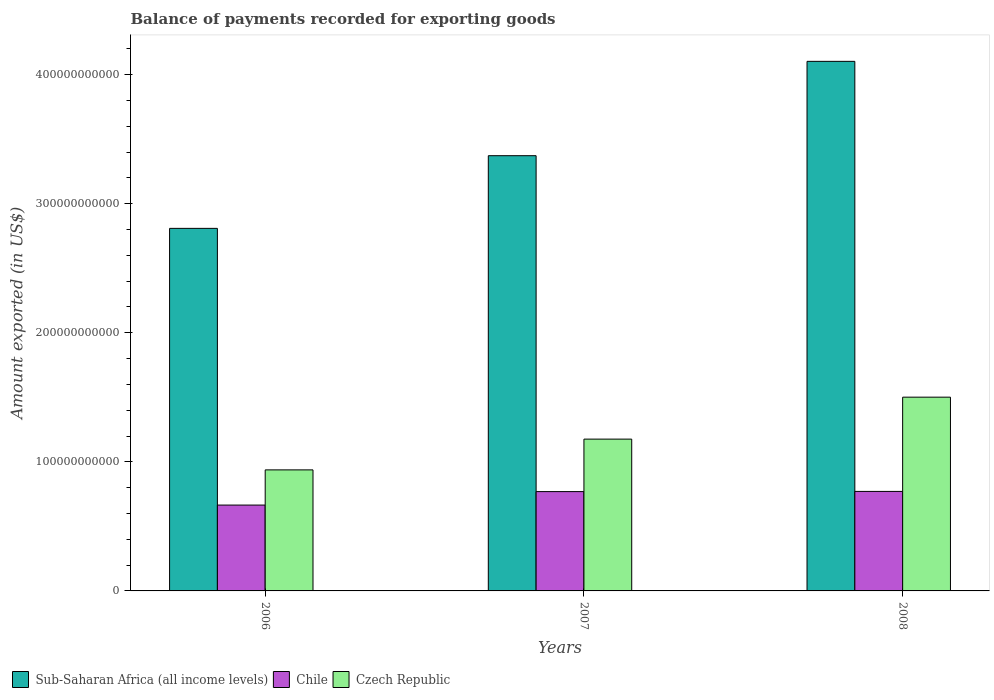How many groups of bars are there?
Offer a terse response. 3. Are the number of bars per tick equal to the number of legend labels?
Your answer should be very brief. Yes. How many bars are there on the 1st tick from the right?
Ensure brevity in your answer.  3. What is the label of the 3rd group of bars from the left?
Give a very brief answer. 2008. What is the amount exported in Chile in 2008?
Your response must be concise. 7.71e+1. Across all years, what is the maximum amount exported in Chile?
Provide a short and direct response. 7.71e+1. Across all years, what is the minimum amount exported in Sub-Saharan Africa (all income levels)?
Your answer should be compact. 2.81e+11. What is the total amount exported in Sub-Saharan Africa (all income levels) in the graph?
Offer a very short reply. 1.03e+12. What is the difference between the amount exported in Chile in 2006 and that in 2007?
Your answer should be compact. -1.04e+1. What is the difference between the amount exported in Chile in 2007 and the amount exported in Czech Republic in 2006?
Keep it short and to the point. -1.68e+1. What is the average amount exported in Sub-Saharan Africa (all income levels) per year?
Give a very brief answer. 3.43e+11. In the year 2006, what is the difference between the amount exported in Chile and amount exported in Czech Republic?
Keep it short and to the point. -2.72e+1. What is the ratio of the amount exported in Sub-Saharan Africa (all income levels) in 2007 to that in 2008?
Provide a succinct answer. 0.82. Is the difference between the amount exported in Chile in 2006 and 2007 greater than the difference between the amount exported in Czech Republic in 2006 and 2007?
Offer a very short reply. Yes. What is the difference between the highest and the second highest amount exported in Sub-Saharan Africa (all income levels)?
Make the answer very short. 7.31e+1. What is the difference between the highest and the lowest amount exported in Chile?
Your answer should be very brief. 1.06e+1. In how many years, is the amount exported in Chile greater than the average amount exported in Chile taken over all years?
Ensure brevity in your answer.  2. What does the 2nd bar from the left in 2006 represents?
Ensure brevity in your answer.  Chile. What does the 3rd bar from the right in 2008 represents?
Keep it short and to the point. Sub-Saharan Africa (all income levels). Is it the case that in every year, the sum of the amount exported in Sub-Saharan Africa (all income levels) and amount exported in Chile is greater than the amount exported in Czech Republic?
Your answer should be compact. Yes. How many bars are there?
Offer a terse response. 9. Are all the bars in the graph horizontal?
Provide a short and direct response. No. What is the difference between two consecutive major ticks on the Y-axis?
Your answer should be very brief. 1.00e+11. Are the values on the major ticks of Y-axis written in scientific E-notation?
Give a very brief answer. No. Does the graph contain any zero values?
Offer a terse response. No. How are the legend labels stacked?
Your response must be concise. Horizontal. What is the title of the graph?
Keep it short and to the point. Balance of payments recorded for exporting goods. Does "Iraq" appear as one of the legend labels in the graph?
Ensure brevity in your answer.  No. What is the label or title of the X-axis?
Give a very brief answer. Years. What is the label or title of the Y-axis?
Offer a very short reply. Amount exported (in US$). What is the Amount exported (in US$) in Sub-Saharan Africa (all income levels) in 2006?
Provide a short and direct response. 2.81e+11. What is the Amount exported (in US$) in Chile in 2006?
Provide a short and direct response. 6.65e+1. What is the Amount exported (in US$) of Czech Republic in 2006?
Your response must be concise. 9.38e+1. What is the Amount exported (in US$) in Sub-Saharan Africa (all income levels) in 2007?
Provide a short and direct response. 3.37e+11. What is the Amount exported (in US$) in Chile in 2007?
Your answer should be compact. 7.69e+1. What is the Amount exported (in US$) of Czech Republic in 2007?
Your answer should be very brief. 1.18e+11. What is the Amount exported (in US$) of Sub-Saharan Africa (all income levels) in 2008?
Ensure brevity in your answer.  4.10e+11. What is the Amount exported (in US$) in Chile in 2008?
Your answer should be compact. 7.71e+1. What is the Amount exported (in US$) in Czech Republic in 2008?
Your answer should be very brief. 1.50e+11. Across all years, what is the maximum Amount exported (in US$) of Sub-Saharan Africa (all income levels)?
Offer a terse response. 4.10e+11. Across all years, what is the maximum Amount exported (in US$) in Chile?
Provide a succinct answer. 7.71e+1. Across all years, what is the maximum Amount exported (in US$) in Czech Republic?
Provide a succinct answer. 1.50e+11. Across all years, what is the minimum Amount exported (in US$) in Sub-Saharan Africa (all income levels)?
Your answer should be compact. 2.81e+11. Across all years, what is the minimum Amount exported (in US$) of Chile?
Offer a very short reply. 6.65e+1. Across all years, what is the minimum Amount exported (in US$) of Czech Republic?
Keep it short and to the point. 9.38e+1. What is the total Amount exported (in US$) in Sub-Saharan Africa (all income levels) in the graph?
Give a very brief answer. 1.03e+12. What is the total Amount exported (in US$) in Chile in the graph?
Keep it short and to the point. 2.21e+11. What is the total Amount exported (in US$) in Czech Republic in the graph?
Give a very brief answer. 3.61e+11. What is the difference between the Amount exported (in US$) in Sub-Saharan Africa (all income levels) in 2006 and that in 2007?
Keep it short and to the point. -5.63e+1. What is the difference between the Amount exported (in US$) of Chile in 2006 and that in 2007?
Offer a terse response. -1.04e+1. What is the difference between the Amount exported (in US$) in Czech Republic in 2006 and that in 2007?
Ensure brevity in your answer.  -2.38e+1. What is the difference between the Amount exported (in US$) of Sub-Saharan Africa (all income levels) in 2006 and that in 2008?
Your answer should be very brief. -1.29e+11. What is the difference between the Amount exported (in US$) in Chile in 2006 and that in 2008?
Your answer should be very brief. -1.06e+1. What is the difference between the Amount exported (in US$) in Czech Republic in 2006 and that in 2008?
Give a very brief answer. -5.63e+1. What is the difference between the Amount exported (in US$) of Sub-Saharan Africa (all income levels) in 2007 and that in 2008?
Provide a short and direct response. -7.31e+1. What is the difference between the Amount exported (in US$) in Chile in 2007 and that in 2008?
Offer a terse response. -1.48e+08. What is the difference between the Amount exported (in US$) of Czech Republic in 2007 and that in 2008?
Ensure brevity in your answer.  -3.25e+1. What is the difference between the Amount exported (in US$) of Sub-Saharan Africa (all income levels) in 2006 and the Amount exported (in US$) of Chile in 2007?
Make the answer very short. 2.04e+11. What is the difference between the Amount exported (in US$) of Sub-Saharan Africa (all income levels) in 2006 and the Amount exported (in US$) of Czech Republic in 2007?
Your answer should be compact. 1.63e+11. What is the difference between the Amount exported (in US$) in Chile in 2006 and the Amount exported (in US$) in Czech Republic in 2007?
Your answer should be compact. -5.11e+1. What is the difference between the Amount exported (in US$) in Sub-Saharan Africa (all income levels) in 2006 and the Amount exported (in US$) in Chile in 2008?
Make the answer very short. 2.04e+11. What is the difference between the Amount exported (in US$) in Sub-Saharan Africa (all income levels) in 2006 and the Amount exported (in US$) in Czech Republic in 2008?
Offer a very short reply. 1.31e+11. What is the difference between the Amount exported (in US$) in Chile in 2006 and the Amount exported (in US$) in Czech Republic in 2008?
Your answer should be very brief. -8.36e+1. What is the difference between the Amount exported (in US$) of Sub-Saharan Africa (all income levels) in 2007 and the Amount exported (in US$) of Chile in 2008?
Make the answer very short. 2.60e+11. What is the difference between the Amount exported (in US$) of Sub-Saharan Africa (all income levels) in 2007 and the Amount exported (in US$) of Czech Republic in 2008?
Your response must be concise. 1.87e+11. What is the difference between the Amount exported (in US$) of Chile in 2007 and the Amount exported (in US$) of Czech Republic in 2008?
Make the answer very short. -7.32e+1. What is the average Amount exported (in US$) of Sub-Saharan Africa (all income levels) per year?
Provide a short and direct response. 3.43e+11. What is the average Amount exported (in US$) of Chile per year?
Your response must be concise. 7.35e+1. What is the average Amount exported (in US$) of Czech Republic per year?
Provide a short and direct response. 1.20e+11. In the year 2006, what is the difference between the Amount exported (in US$) in Sub-Saharan Africa (all income levels) and Amount exported (in US$) in Chile?
Offer a very short reply. 2.14e+11. In the year 2006, what is the difference between the Amount exported (in US$) in Sub-Saharan Africa (all income levels) and Amount exported (in US$) in Czech Republic?
Ensure brevity in your answer.  1.87e+11. In the year 2006, what is the difference between the Amount exported (in US$) in Chile and Amount exported (in US$) in Czech Republic?
Your response must be concise. -2.72e+1. In the year 2007, what is the difference between the Amount exported (in US$) in Sub-Saharan Africa (all income levels) and Amount exported (in US$) in Chile?
Your response must be concise. 2.60e+11. In the year 2007, what is the difference between the Amount exported (in US$) in Sub-Saharan Africa (all income levels) and Amount exported (in US$) in Czech Republic?
Provide a succinct answer. 2.20e+11. In the year 2007, what is the difference between the Amount exported (in US$) in Chile and Amount exported (in US$) in Czech Republic?
Ensure brevity in your answer.  -4.07e+1. In the year 2008, what is the difference between the Amount exported (in US$) in Sub-Saharan Africa (all income levels) and Amount exported (in US$) in Chile?
Offer a terse response. 3.33e+11. In the year 2008, what is the difference between the Amount exported (in US$) in Sub-Saharan Africa (all income levels) and Amount exported (in US$) in Czech Republic?
Your response must be concise. 2.60e+11. In the year 2008, what is the difference between the Amount exported (in US$) of Chile and Amount exported (in US$) of Czech Republic?
Make the answer very short. -7.30e+1. What is the ratio of the Amount exported (in US$) in Sub-Saharan Africa (all income levels) in 2006 to that in 2007?
Provide a short and direct response. 0.83. What is the ratio of the Amount exported (in US$) in Chile in 2006 to that in 2007?
Your answer should be compact. 0.86. What is the ratio of the Amount exported (in US$) in Czech Republic in 2006 to that in 2007?
Your answer should be compact. 0.8. What is the ratio of the Amount exported (in US$) of Sub-Saharan Africa (all income levels) in 2006 to that in 2008?
Offer a very short reply. 0.68. What is the ratio of the Amount exported (in US$) of Chile in 2006 to that in 2008?
Provide a short and direct response. 0.86. What is the ratio of the Amount exported (in US$) in Czech Republic in 2006 to that in 2008?
Make the answer very short. 0.62. What is the ratio of the Amount exported (in US$) in Sub-Saharan Africa (all income levels) in 2007 to that in 2008?
Provide a short and direct response. 0.82. What is the ratio of the Amount exported (in US$) in Czech Republic in 2007 to that in 2008?
Ensure brevity in your answer.  0.78. What is the difference between the highest and the second highest Amount exported (in US$) in Sub-Saharan Africa (all income levels)?
Your answer should be compact. 7.31e+1. What is the difference between the highest and the second highest Amount exported (in US$) of Chile?
Your response must be concise. 1.48e+08. What is the difference between the highest and the second highest Amount exported (in US$) of Czech Republic?
Provide a short and direct response. 3.25e+1. What is the difference between the highest and the lowest Amount exported (in US$) of Sub-Saharan Africa (all income levels)?
Offer a terse response. 1.29e+11. What is the difference between the highest and the lowest Amount exported (in US$) in Chile?
Offer a very short reply. 1.06e+1. What is the difference between the highest and the lowest Amount exported (in US$) in Czech Republic?
Give a very brief answer. 5.63e+1. 